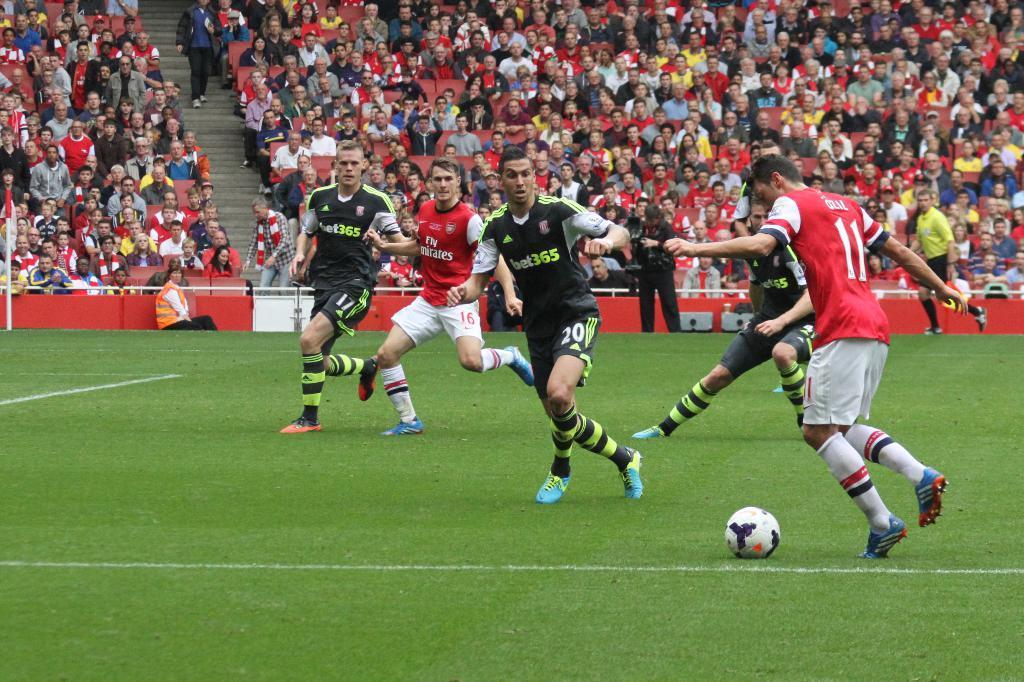Can you describe this image briefly? In this image there is a playground at the bottom, there are few persons playing a game, there is a ball visible on the ground, in the middle there is the fence in the middle, behind the fence there is crowd visible. 